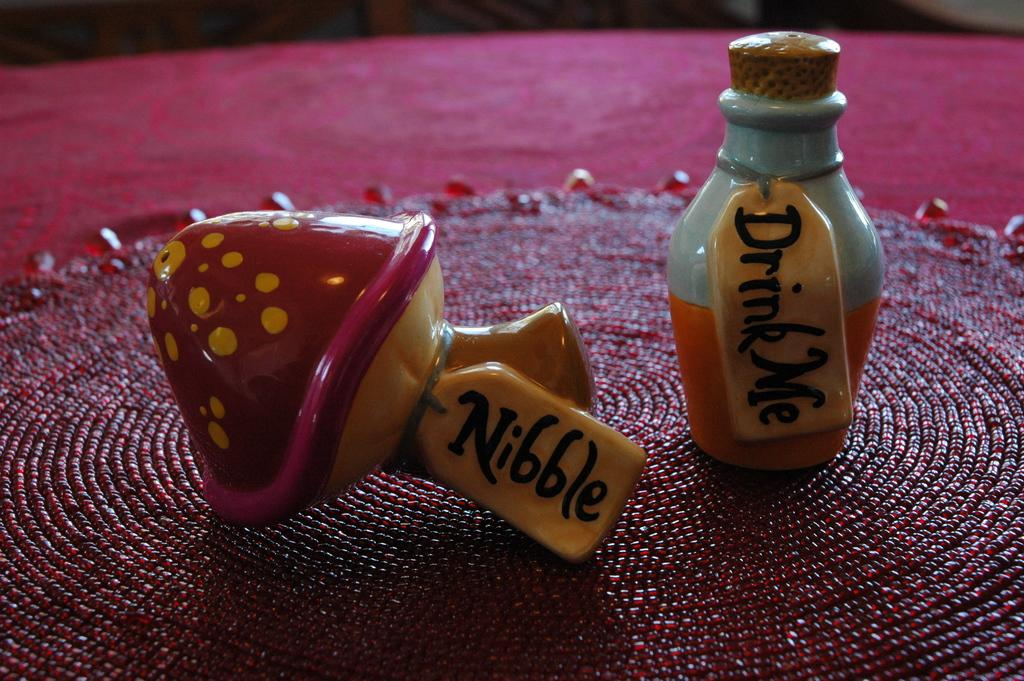Provide a one-sentence caption for the provided image. Hand made drink me bottle and mushroom that says nibble. 